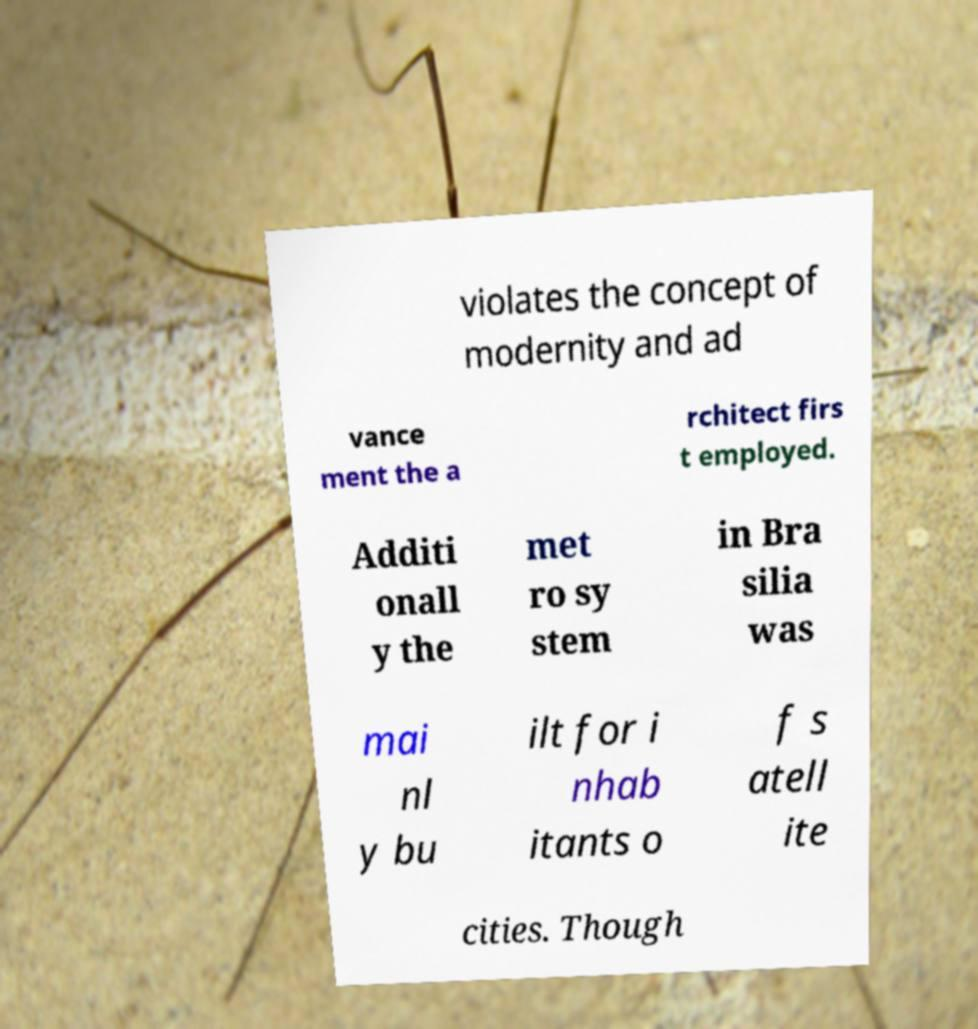Can you accurately transcribe the text from the provided image for me? violates the concept of modernity and ad vance ment the a rchitect firs t employed. Additi onall y the met ro sy stem in Bra silia was mai nl y bu ilt for i nhab itants o f s atell ite cities. Though 